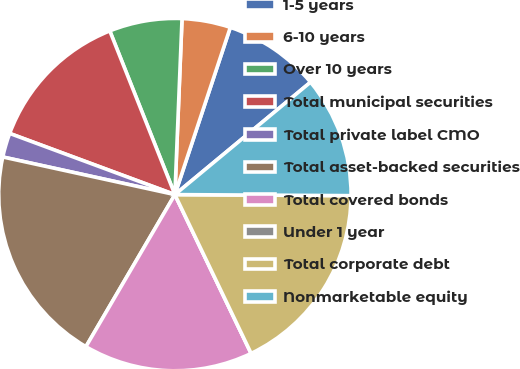Convert chart. <chart><loc_0><loc_0><loc_500><loc_500><pie_chart><fcel>1-5 years<fcel>6-10 years<fcel>Over 10 years<fcel>Total municipal securities<fcel>Total private label CMO<fcel>Total asset-backed securities<fcel>Total covered bonds<fcel>Under 1 year<fcel>Total corporate debt<fcel>Nonmarketable equity<nl><fcel>8.89%<fcel>4.45%<fcel>6.67%<fcel>13.33%<fcel>2.22%<fcel>20.0%<fcel>15.55%<fcel>0.0%<fcel>17.78%<fcel>11.11%<nl></chart> 